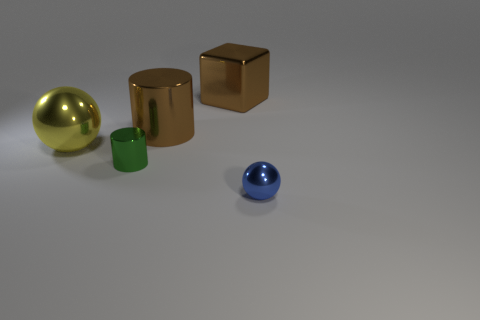Add 3 small balls. How many objects exist? 8 Subtract all green blocks. Subtract all cyan cylinders. How many blocks are left? 1 Subtract all blocks. How many objects are left? 4 Add 5 big green shiny objects. How many big green shiny objects exist? 5 Subtract 1 yellow balls. How many objects are left? 4 Subtract all small rubber cylinders. Subtract all brown metallic objects. How many objects are left? 3 Add 1 big spheres. How many big spheres are left? 2 